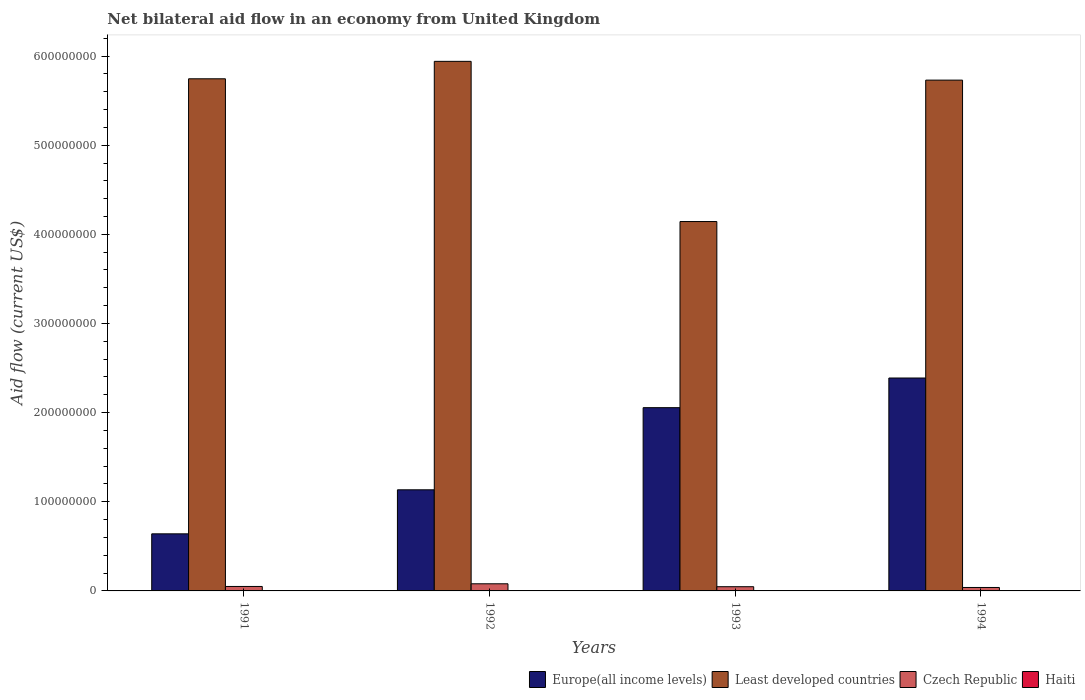How many groups of bars are there?
Your answer should be compact. 4. Are the number of bars on each tick of the X-axis equal?
Provide a succinct answer. Yes. In how many cases, is the number of bars for a given year not equal to the number of legend labels?
Your answer should be very brief. 0. What is the net bilateral aid flow in Czech Republic in 1992?
Give a very brief answer. 8.00e+06. Across all years, what is the maximum net bilateral aid flow in Czech Republic?
Give a very brief answer. 8.00e+06. In which year was the net bilateral aid flow in Europe(all income levels) maximum?
Your answer should be very brief. 1994. What is the total net bilateral aid flow in Least developed countries in the graph?
Ensure brevity in your answer.  2.16e+09. What is the difference between the net bilateral aid flow in Europe(all income levels) in 1991 and that in 1994?
Ensure brevity in your answer.  -1.75e+08. What is the difference between the net bilateral aid flow in Europe(all income levels) in 1992 and the net bilateral aid flow in Haiti in 1994?
Keep it short and to the point. 1.13e+08. What is the average net bilateral aid flow in Czech Republic per year?
Keep it short and to the point. 5.40e+06. In the year 1992, what is the difference between the net bilateral aid flow in Czech Republic and net bilateral aid flow in Europe(all income levels)?
Your answer should be compact. -1.05e+08. In how many years, is the net bilateral aid flow in Czech Republic greater than 80000000 US$?
Your response must be concise. 0. What is the ratio of the net bilateral aid flow in Europe(all income levels) in 1992 to that in 1994?
Your answer should be compact. 0.47. Is the difference between the net bilateral aid flow in Czech Republic in 1991 and 1993 greater than the difference between the net bilateral aid flow in Europe(all income levels) in 1991 and 1993?
Offer a very short reply. Yes. What is the difference between the highest and the second highest net bilateral aid flow in Least developed countries?
Give a very brief answer. 1.96e+07. What is the difference between the highest and the lowest net bilateral aid flow in Europe(all income levels)?
Your response must be concise. 1.75e+08. Is the sum of the net bilateral aid flow in Czech Republic in 1991 and 1994 greater than the maximum net bilateral aid flow in Least developed countries across all years?
Offer a terse response. No. What does the 3rd bar from the left in 1993 represents?
Offer a terse response. Czech Republic. What does the 1st bar from the right in 1993 represents?
Offer a terse response. Haiti. Is it the case that in every year, the sum of the net bilateral aid flow in Europe(all income levels) and net bilateral aid flow in Czech Republic is greater than the net bilateral aid flow in Haiti?
Ensure brevity in your answer.  Yes. How many bars are there?
Your response must be concise. 16. Are all the bars in the graph horizontal?
Make the answer very short. No. Are the values on the major ticks of Y-axis written in scientific E-notation?
Make the answer very short. No. Does the graph contain any zero values?
Provide a succinct answer. No. Does the graph contain grids?
Make the answer very short. No. How many legend labels are there?
Make the answer very short. 4. What is the title of the graph?
Make the answer very short. Net bilateral aid flow in an economy from United Kingdom. Does "New Zealand" appear as one of the legend labels in the graph?
Your response must be concise. No. What is the Aid flow (current US$) of Europe(all income levels) in 1991?
Your response must be concise. 6.40e+07. What is the Aid flow (current US$) in Least developed countries in 1991?
Give a very brief answer. 5.74e+08. What is the Aid flow (current US$) of Europe(all income levels) in 1992?
Keep it short and to the point. 1.13e+08. What is the Aid flow (current US$) in Least developed countries in 1992?
Give a very brief answer. 5.94e+08. What is the Aid flow (current US$) in Europe(all income levels) in 1993?
Provide a short and direct response. 2.06e+08. What is the Aid flow (current US$) of Least developed countries in 1993?
Give a very brief answer. 4.14e+08. What is the Aid flow (current US$) in Czech Republic in 1993?
Your response must be concise. 4.73e+06. What is the Aid flow (current US$) in Europe(all income levels) in 1994?
Your response must be concise. 2.39e+08. What is the Aid flow (current US$) of Least developed countries in 1994?
Offer a terse response. 5.73e+08. What is the Aid flow (current US$) in Czech Republic in 1994?
Provide a succinct answer. 3.86e+06. What is the Aid flow (current US$) in Haiti in 1994?
Your answer should be compact. 4.50e+05. Across all years, what is the maximum Aid flow (current US$) of Europe(all income levels)?
Offer a terse response. 2.39e+08. Across all years, what is the maximum Aid flow (current US$) of Least developed countries?
Provide a succinct answer. 5.94e+08. Across all years, what is the minimum Aid flow (current US$) in Europe(all income levels)?
Give a very brief answer. 6.40e+07. Across all years, what is the minimum Aid flow (current US$) of Least developed countries?
Offer a terse response. 4.14e+08. Across all years, what is the minimum Aid flow (current US$) in Czech Republic?
Provide a short and direct response. 3.86e+06. Across all years, what is the minimum Aid flow (current US$) of Haiti?
Your answer should be compact. 4.00e+04. What is the total Aid flow (current US$) of Europe(all income levels) in the graph?
Ensure brevity in your answer.  6.22e+08. What is the total Aid flow (current US$) of Least developed countries in the graph?
Your answer should be very brief. 2.16e+09. What is the total Aid flow (current US$) in Czech Republic in the graph?
Give a very brief answer. 2.16e+07. What is the total Aid flow (current US$) of Haiti in the graph?
Keep it short and to the point. 9.70e+05. What is the difference between the Aid flow (current US$) of Europe(all income levels) in 1991 and that in 1992?
Your answer should be very brief. -4.94e+07. What is the difference between the Aid flow (current US$) in Least developed countries in 1991 and that in 1992?
Offer a terse response. -1.96e+07. What is the difference between the Aid flow (current US$) in Czech Republic in 1991 and that in 1992?
Ensure brevity in your answer.  -3.00e+06. What is the difference between the Aid flow (current US$) of Haiti in 1991 and that in 1992?
Your answer should be very brief. -2.50e+05. What is the difference between the Aid flow (current US$) of Europe(all income levels) in 1991 and that in 1993?
Offer a very short reply. -1.42e+08. What is the difference between the Aid flow (current US$) of Least developed countries in 1991 and that in 1993?
Provide a succinct answer. 1.60e+08. What is the difference between the Aid flow (current US$) of Haiti in 1991 and that in 1993?
Provide a succinct answer. -1.50e+05. What is the difference between the Aid flow (current US$) of Europe(all income levels) in 1991 and that in 1994?
Provide a short and direct response. -1.75e+08. What is the difference between the Aid flow (current US$) in Least developed countries in 1991 and that in 1994?
Ensure brevity in your answer.  1.49e+06. What is the difference between the Aid flow (current US$) in Czech Republic in 1991 and that in 1994?
Give a very brief answer. 1.14e+06. What is the difference between the Aid flow (current US$) in Haiti in 1991 and that in 1994?
Offer a very short reply. -4.10e+05. What is the difference between the Aid flow (current US$) in Europe(all income levels) in 1992 and that in 1993?
Ensure brevity in your answer.  -9.21e+07. What is the difference between the Aid flow (current US$) in Least developed countries in 1992 and that in 1993?
Your response must be concise. 1.80e+08. What is the difference between the Aid flow (current US$) of Czech Republic in 1992 and that in 1993?
Give a very brief answer. 3.27e+06. What is the difference between the Aid flow (current US$) in Europe(all income levels) in 1992 and that in 1994?
Offer a very short reply. -1.25e+08. What is the difference between the Aid flow (current US$) in Least developed countries in 1992 and that in 1994?
Offer a terse response. 2.10e+07. What is the difference between the Aid flow (current US$) in Czech Republic in 1992 and that in 1994?
Ensure brevity in your answer.  4.14e+06. What is the difference between the Aid flow (current US$) of Europe(all income levels) in 1993 and that in 1994?
Ensure brevity in your answer.  -3.33e+07. What is the difference between the Aid flow (current US$) of Least developed countries in 1993 and that in 1994?
Keep it short and to the point. -1.59e+08. What is the difference between the Aid flow (current US$) of Czech Republic in 1993 and that in 1994?
Offer a very short reply. 8.70e+05. What is the difference between the Aid flow (current US$) in Haiti in 1993 and that in 1994?
Keep it short and to the point. -2.60e+05. What is the difference between the Aid flow (current US$) of Europe(all income levels) in 1991 and the Aid flow (current US$) of Least developed countries in 1992?
Provide a succinct answer. -5.30e+08. What is the difference between the Aid flow (current US$) of Europe(all income levels) in 1991 and the Aid flow (current US$) of Czech Republic in 1992?
Your answer should be compact. 5.60e+07. What is the difference between the Aid flow (current US$) in Europe(all income levels) in 1991 and the Aid flow (current US$) in Haiti in 1992?
Your response must be concise. 6.38e+07. What is the difference between the Aid flow (current US$) of Least developed countries in 1991 and the Aid flow (current US$) of Czech Republic in 1992?
Provide a short and direct response. 5.66e+08. What is the difference between the Aid flow (current US$) in Least developed countries in 1991 and the Aid flow (current US$) in Haiti in 1992?
Offer a very short reply. 5.74e+08. What is the difference between the Aid flow (current US$) of Czech Republic in 1991 and the Aid flow (current US$) of Haiti in 1992?
Give a very brief answer. 4.71e+06. What is the difference between the Aid flow (current US$) in Europe(all income levels) in 1991 and the Aid flow (current US$) in Least developed countries in 1993?
Provide a succinct answer. -3.50e+08. What is the difference between the Aid flow (current US$) of Europe(all income levels) in 1991 and the Aid flow (current US$) of Czech Republic in 1993?
Offer a terse response. 5.93e+07. What is the difference between the Aid flow (current US$) in Europe(all income levels) in 1991 and the Aid flow (current US$) in Haiti in 1993?
Your response must be concise. 6.38e+07. What is the difference between the Aid flow (current US$) of Least developed countries in 1991 and the Aid flow (current US$) of Czech Republic in 1993?
Your answer should be very brief. 5.70e+08. What is the difference between the Aid flow (current US$) in Least developed countries in 1991 and the Aid flow (current US$) in Haiti in 1993?
Your response must be concise. 5.74e+08. What is the difference between the Aid flow (current US$) of Czech Republic in 1991 and the Aid flow (current US$) of Haiti in 1993?
Provide a succinct answer. 4.81e+06. What is the difference between the Aid flow (current US$) of Europe(all income levels) in 1991 and the Aid flow (current US$) of Least developed countries in 1994?
Provide a succinct answer. -5.09e+08. What is the difference between the Aid flow (current US$) of Europe(all income levels) in 1991 and the Aid flow (current US$) of Czech Republic in 1994?
Keep it short and to the point. 6.02e+07. What is the difference between the Aid flow (current US$) in Europe(all income levels) in 1991 and the Aid flow (current US$) in Haiti in 1994?
Offer a very short reply. 6.36e+07. What is the difference between the Aid flow (current US$) of Least developed countries in 1991 and the Aid flow (current US$) of Czech Republic in 1994?
Offer a very short reply. 5.71e+08. What is the difference between the Aid flow (current US$) in Least developed countries in 1991 and the Aid flow (current US$) in Haiti in 1994?
Provide a succinct answer. 5.74e+08. What is the difference between the Aid flow (current US$) of Czech Republic in 1991 and the Aid flow (current US$) of Haiti in 1994?
Give a very brief answer. 4.55e+06. What is the difference between the Aid flow (current US$) in Europe(all income levels) in 1992 and the Aid flow (current US$) in Least developed countries in 1993?
Keep it short and to the point. -3.01e+08. What is the difference between the Aid flow (current US$) of Europe(all income levels) in 1992 and the Aid flow (current US$) of Czech Republic in 1993?
Offer a terse response. 1.09e+08. What is the difference between the Aid flow (current US$) in Europe(all income levels) in 1992 and the Aid flow (current US$) in Haiti in 1993?
Ensure brevity in your answer.  1.13e+08. What is the difference between the Aid flow (current US$) of Least developed countries in 1992 and the Aid flow (current US$) of Czech Republic in 1993?
Your answer should be compact. 5.89e+08. What is the difference between the Aid flow (current US$) of Least developed countries in 1992 and the Aid flow (current US$) of Haiti in 1993?
Your answer should be compact. 5.94e+08. What is the difference between the Aid flow (current US$) of Czech Republic in 1992 and the Aid flow (current US$) of Haiti in 1993?
Your answer should be very brief. 7.81e+06. What is the difference between the Aid flow (current US$) of Europe(all income levels) in 1992 and the Aid flow (current US$) of Least developed countries in 1994?
Provide a short and direct response. -4.60e+08. What is the difference between the Aid flow (current US$) in Europe(all income levels) in 1992 and the Aid flow (current US$) in Czech Republic in 1994?
Offer a terse response. 1.10e+08. What is the difference between the Aid flow (current US$) in Europe(all income levels) in 1992 and the Aid flow (current US$) in Haiti in 1994?
Provide a succinct answer. 1.13e+08. What is the difference between the Aid flow (current US$) in Least developed countries in 1992 and the Aid flow (current US$) in Czech Republic in 1994?
Make the answer very short. 5.90e+08. What is the difference between the Aid flow (current US$) of Least developed countries in 1992 and the Aid flow (current US$) of Haiti in 1994?
Your answer should be compact. 5.94e+08. What is the difference between the Aid flow (current US$) in Czech Republic in 1992 and the Aid flow (current US$) in Haiti in 1994?
Provide a succinct answer. 7.55e+06. What is the difference between the Aid flow (current US$) in Europe(all income levels) in 1993 and the Aid flow (current US$) in Least developed countries in 1994?
Give a very brief answer. -3.67e+08. What is the difference between the Aid flow (current US$) of Europe(all income levels) in 1993 and the Aid flow (current US$) of Czech Republic in 1994?
Provide a short and direct response. 2.02e+08. What is the difference between the Aid flow (current US$) of Europe(all income levels) in 1993 and the Aid flow (current US$) of Haiti in 1994?
Make the answer very short. 2.05e+08. What is the difference between the Aid flow (current US$) in Least developed countries in 1993 and the Aid flow (current US$) in Czech Republic in 1994?
Give a very brief answer. 4.10e+08. What is the difference between the Aid flow (current US$) of Least developed countries in 1993 and the Aid flow (current US$) of Haiti in 1994?
Give a very brief answer. 4.14e+08. What is the difference between the Aid flow (current US$) of Czech Republic in 1993 and the Aid flow (current US$) of Haiti in 1994?
Offer a terse response. 4.28e+06. What is the average Aid flow (current US$) of Europe(all income levels) per year?
Your response must be concise. 1.55e+08. What is the average Aid flow (current US$) of Least developed countries per year?
Your answer should be compact. 5.39e+08. What is the average Aid flow (current US$) of Czech Republic per year?
Give a very brief answer. 5.40e+06. What is the average Aid flow (current US$) of Haiti per year?
Offer a very short reply. 2.42e+05. In the year 1991, what is the difference between the Aid flow (current US$) in Europe(all income levels) and Aid flow (current US$) in Least developed countries?
Provide a succinct answer. -5.10e+08. In the year 1991, what is the difference between the Aid flow (current US$) in Europe(all income levels) and Aid flow (current US$) in Czech Republic?
Make the answer very short. 5.90e+07. In the year 1991, what is the difference between the Aid flow (current US$) in Europe(all income levels) and Aid flow (current US$) in Haiti?
Make the answer very short. 6.40e+07. In the year 1991, what is the difference between the Aid flow (current US$) in Least developed countries and Aid flow (current US$) in Czech Republic?
Provide a succinct answer. 5.69e+08. In the year 1991, what is the difference between the Aid flow (current US$) of Least developed countries and Aid flow (current US$) of Haiti?
Offer a terse response. 5.74e+08. In the year 1991, what is the difference between the Aid flow (current US$) of Czech Republic and Aid flow (current US$) of Haiti?
Your response must be concise. 4.96e+06. In the year 1992, what is the difference between the Aid flow (current US$) in Europe(all income levels) and Aid flow (current US$) in Least developed countries?
Your answer should be compact. -4.81e+08. In the year 1992, what is the difference between the Aid flow (current US$) of Europe(all income levels) and Aid flow (current US$) of Czech Republic?
Give a very brief answer. 1.05e+08. In the year 1992, what is the difference between the Aid flow (current US$) of Europe(all income levels) and Aid flow (current US$) of Haiti?
Provide a succinct answer. 1.13e+08. In the year 1992, what is the difference between the Aid flow (current US$) in Least developed countries and Aid flow (current US$) in Czech Republic?
Your answer should be compact. 5.86e+08. In the year 1992, what is the difference between the Aid flow (current US$) in Least developed countries and Aid flow (current US$) in Haiti?
Give a very brief answer. 5.94e+08. In the year 1992, what is the difference between the Aid flow (current US$) of Czech Republic and Aid flow (current US$) of Haiti?
Your answer should be very brief. 7.71e+06. In the year 1993, what is the difference between the Aid flow (current US$) in Europe(all income levels) and Aid flow (current US$) in Least developed countries?
Keep it short and to the point. -2.09e+08. In the year 1993, what is the difference between the Aid flow (current US$) of Europe(all income levels) and Aid flow (current US$) of Czech Republic?
Make the answer very short. 2.01e+08. In the year 1993, what is the difference between the Aid flow (current US$) of Europe(all income levels) and Aid flow (current US$) of Haiti?
Provide a succinct answer. 2.05e+08. In the year 1993, what is the difference between the Aid flow (current US$) in Least developed countries and Aid flow (current US$) in Czech Republic?
Your answer should be very brief. 4.10e+08. In the year 1993, what is the difference between the Aid flow (current US$) in Least developed countries and Aid flow (current US$) in Haiti?
Your answer should be very brief. 4.14e+08. In the year 1993, what is the difference between the Aid flow (current US$) of Czech Republic and Aid flow (current US$) of Haiti?
Give a very brief answer. 4.54e+06. In the year 1994, what is the difference between the Aid flow (current US$) of Europe(all income levels) and Aid flow (current US$) of Least developed countries?
Your answer should be compact. -3.34e+08. In the year 1994, what is the difference between the Aid flow (current US$) of Europe(all income levels) and Aid flow (current US$) of Czech Republic?
Ensure brevity in your answer.  2.35e+08. In the year 1994, what is the difference between the Aid flow (current US$) in Europe(all income levels) and Aid flow (current US$) in Haiti?
Give a very brief answer. 2.38e+08. In the year 1994, what is the difference between the Aid flow (current US$) of Least developed countries and Aid flow (current US$) of Czech Republic?
Provide a succinct answer. 5.69e+08. In the year 1994, what is the difference between the Aid flow (current US$) of Least developed countries and Aid flow (current US$) of Haiti?
Your answer should be very brief. 5.73e+08. In the year 1994, what is the difference between the Aid flow (current US$) in Czech Republic and Aid flow (current US$) in Haiti?
Give a very brief answer. 3.41e+06. What is the ratio of the Aid flow (current US$) in Europe(all income levels) in 1991 to that in 1992?
Offer a terse response. 0.56. What is the ratio of the Aid flow (current US$) in Least developed countries in 1991 to that in 1992?
Your answer should be compact. 0.97. What is the ratio of the Aid flow (current US$) of Czech Republic in 1991 to that in 1992?
Make the answer very short. 0.62. What is the ratio of the Aid flow (current US$) of Haiti in 1991 to that in 1992?
Your answer should be compact. 0.14. What is the ratio of the Aid flow (current US$) in Europe(all income levels) in 1991 to that in 1993?
Make the answer very short. 0.31. What is the ratio of the Aid flow (current US$) of Least developed countries in 1991 to that in 1993?
Offer a terse response. 1.39. What is the ratio of the Aid flow (current US$) of Czech Republic in 1991 to that in 1993?
Your answer should be compact. 1.06. What is the ratio of the Aid flow (current US$) of Haiti in 1991 to that in 1993?
Offer a very short reply. 0.21. What is the ratio of the Aid flow (current US$) in Europe(all income levels) in 1991 to that in 1994?
Make the answer very short. 0.27. What is the ratio of the Aid flow (current US$) of Czech Republic in 1991 to that in 1994?
Provide a succinct answer. 1.3. What is the ratio of the Aid flow (current US$) in Haiti in 1991 to that in 1994?
Offer a terse response. 0.09. What is the ratio of the Aid flow (current US$) in Europe(all income levels) in 1992 to that in 1993?
Give a very brief answer. 0.55. What is the ratio of the Aid flow (current US$) of Least developed countries in 1992 to that in 1993?
Your answer should be compact. 1.43. What is the ratio of the Aid flow (current US$) of Czech Republic in 1992 to that in 1993?
Ensure brevity in your answer.  1.69. What is the ratio of the Aid flow (current US$) of Haiti in 1992 to that in 1993?
Provide a succinct answer. 1.53. What is the ratio of the Aid flow (current US$) in Europe(all income levels) in 1992 to that in 1994?
Give a very brief answer. 0.47. What is the ratio of the Aid flow (current US$) of Least developed countries in 1992 to that in 1994?
Provide a short and direct response. 1.04. What is the ratio of the Aid flow (current US$) of Czech Republic in 1992 to that in 1994?
Make the answer very short. 2.07. What is the ratio of the Aid flow (current US$) in Haiti in 1992 to that in 1994?
Provide a short and direct response. 0.64. What is the ratio of the Aid flow (current US$) of Europe(all income levels) in 1993 to that in 1994?
Give a very brief answer. 0.86. What is the ratio of the Aid flow (current US$) in Least developed countries in 1993 to that in 1994?
Your response must be concise. 0.72. What is the ratio of the Aid flow (current US$) of Czech Republic in 1993 to that in 1994?
Give a very brief answer. 1.23. What is the ratio of the Aid flow (current US$) in Haiti in 1993 to that in 1994?
Keep it short and to the point. 0.42. What is the difference between the highest and the second highest Aid flow (current US$) of Europe(all income levels)?
Give a very brief answer. 3.33e+07. What is the difference between the highest and the second highest Aid flow (current US$) in Least developed countries?
Offer a terse response. 1.96e+07. What is the difference between the highest and the second highest Aid flow (current US$) in Haiti?
Provide a succinct answer. 1.60e+05. What is the difference between the highest and the lowest Aid flow (current US$) of Europe(all income levels)?
Offer a terse response. 1.75e+08. What is the difference between the highest and the lowest Aid flow (current US$) of Least developed countries?
Provide a short and direct response. 1.80e+08. What is the difference between the highest and the lowest Aid flow (current US$) in Czech Republic?
Provide a short and direct response. 4.14e+06. 